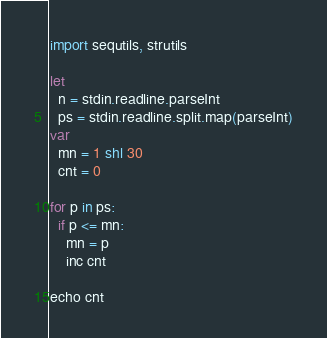<code> <loc_0><loc_0><loc_500><loc_500><_Nim_>import sequtils, strutils

let
  n = stdin.readline.parseInt
  ps = stdin.readline.split.map(parseInt)
var
  mn = 1 shl 30
  cnt = 0

for p in ps:
  if p <= mn:
    mn = p
    inc cnt
  
echo cnt
</code> 